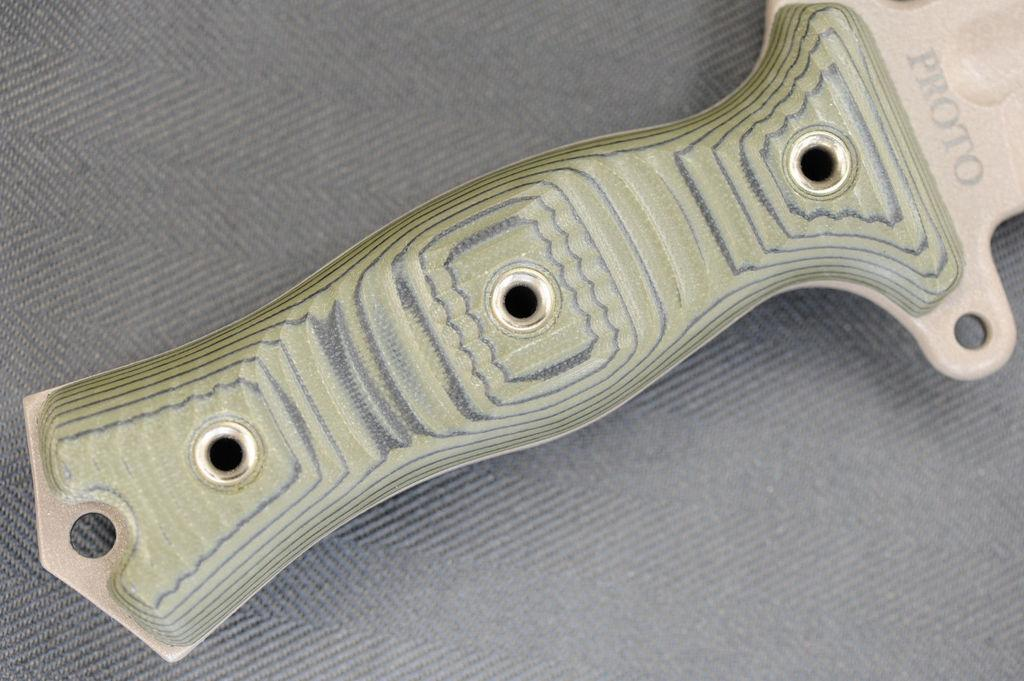What is the main subject of the image? There is an object in the center of the image. What type of pies are being served in the afternoon during the event of shame in the image? There is no mention of pies, afternoon, or shame in the image. The image only contains an object in the center. 